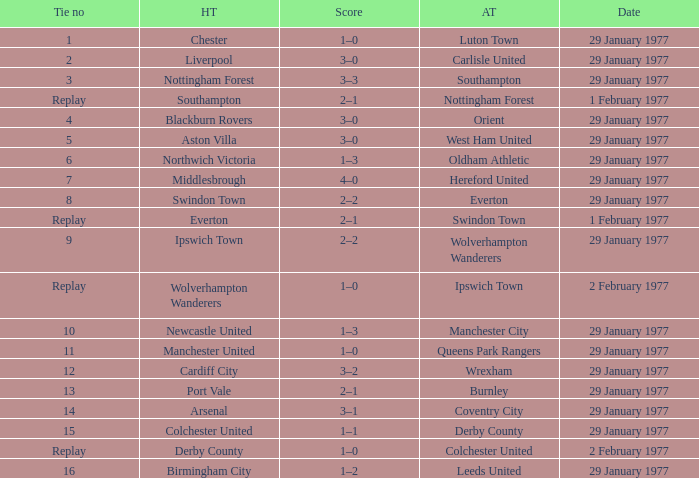Which away team has a tie number of 3? Southampton. 